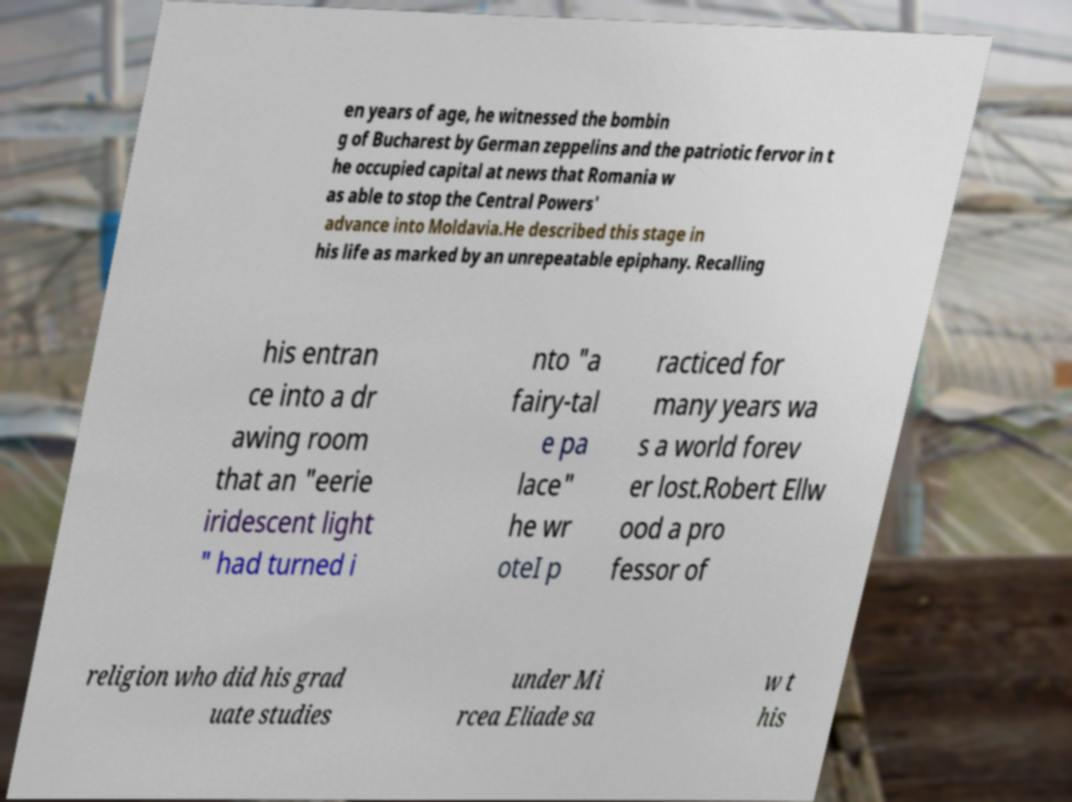Please read and relay the text visible in this image. What does it say? en years of age, he witnessed the bombin g of Bucharest by German zeppelins and the patriotic fervor in t he occupied capital at news that Romania w as able to stop the Central Powers' advance into Moldavia.He described this stage in his life as marked by an unrepeatable epiphany. Recalling his entran ce into a dr awing room that an "eerie iridescent light " had turned i nto "a fairy-tal e pa lace" he wr oteI p racticed for many years wa s a world forev er lost.Robert Ellw ood a pro fessor of religion who did his grad uate studies under Mi rcea Eliade sa w t his 